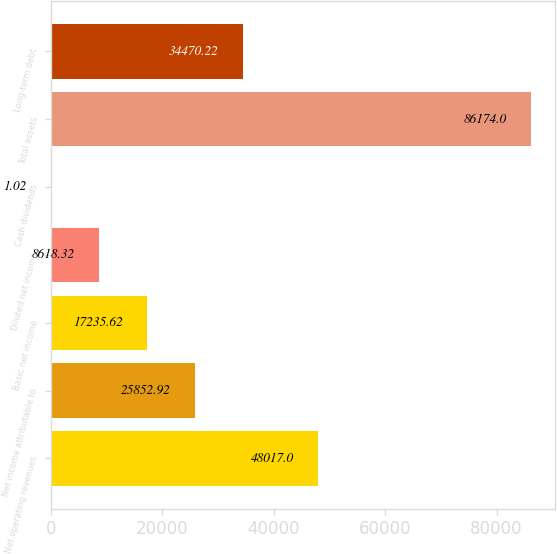<chart> <loc_0><loc_0><loc_500><loc_500><bar_chart><fcel>Net operating revenues<fcel>Net income attributable to<fcel>Basic net income<fcel>Diluted net income<fcel>Cash dividends<fcel>Total assets<fcel>Long-term debt<nl><fcel>48017<fcel>25852.9<fcel>17235.6<fcel>8618.32<fcel>1.02<fcel>86174<fcel>34470.2<nl></chart> 